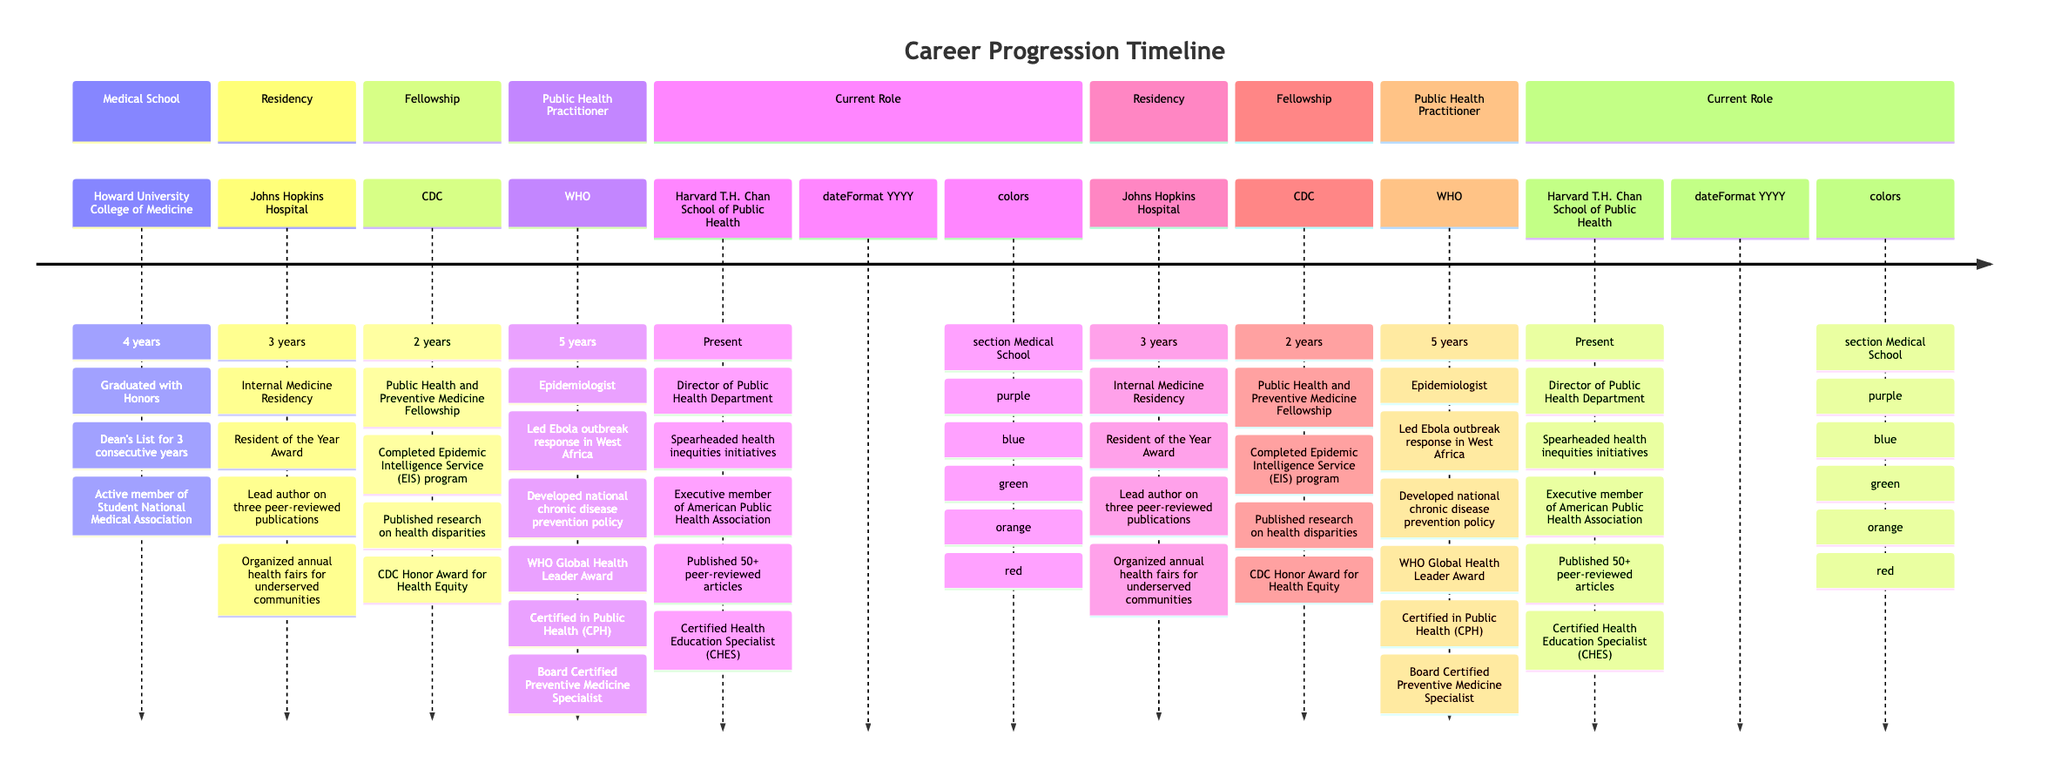What is the total duration of the fellowship stage? The fellowship stage listed in the timeline is for 2 years, as indicated directly in the section detailing the Fellowship program.
Answer: 2 years Which institution did the medical school graduate from? The timeline specifies that the medical school was Howard University College of Medicine, which is mentioned in the Medical School section details.
Answer: Howard University College of Medicine How many peer-reviewed publications did the resident author? The timeline notes that the individual was the lead author on three peer-reviewed publications during the residency stage, giving a specific count.
Answer: Three What is the title of the current role? The current role section states the position as Director of Public Health Department, explicitly defining the role held at this stage in the timeline.
Answer: Director of Public Health Department Which award was received during the fellowship? The timeline highlights that the CDC Honor Award for Health Equity was awarded during the Fellowship stage, thereby directly answering the question regarding achievements in that section.
Answer: CDC Honor Award for Health Equity What was the major achievement during the residency focused on community health? The timeline states that the individual organized annual health fairs for underserved communities, indicating a significant community-focused initiative during the residency.
Answer: Organized annual health fairs for underserved communities Which certification is mentioned in the public health practitioner section? The timeline lists two certifications, one being Certified in Public Health (CPH), which specifically answers the request for a certification mentioned in the Public Health Practitioner stage.
Answer: Certified in Public Health (CPH) How many years did the individual work as an epidemiologist? The diagram indicates a duration of 5 years in the position of Epidemiologist, allowing for a straightforward calculation based on the timeline stage detail.
Answer: 5 years What significant role did the individual have during the Ebola outbreak? The timeline mentions that the person led the response team during the Ebola outbreak in West Africa, thereby identifying their role in this specific public health event.
Answer: Led the response team during Ebola outbreak in West Africa 